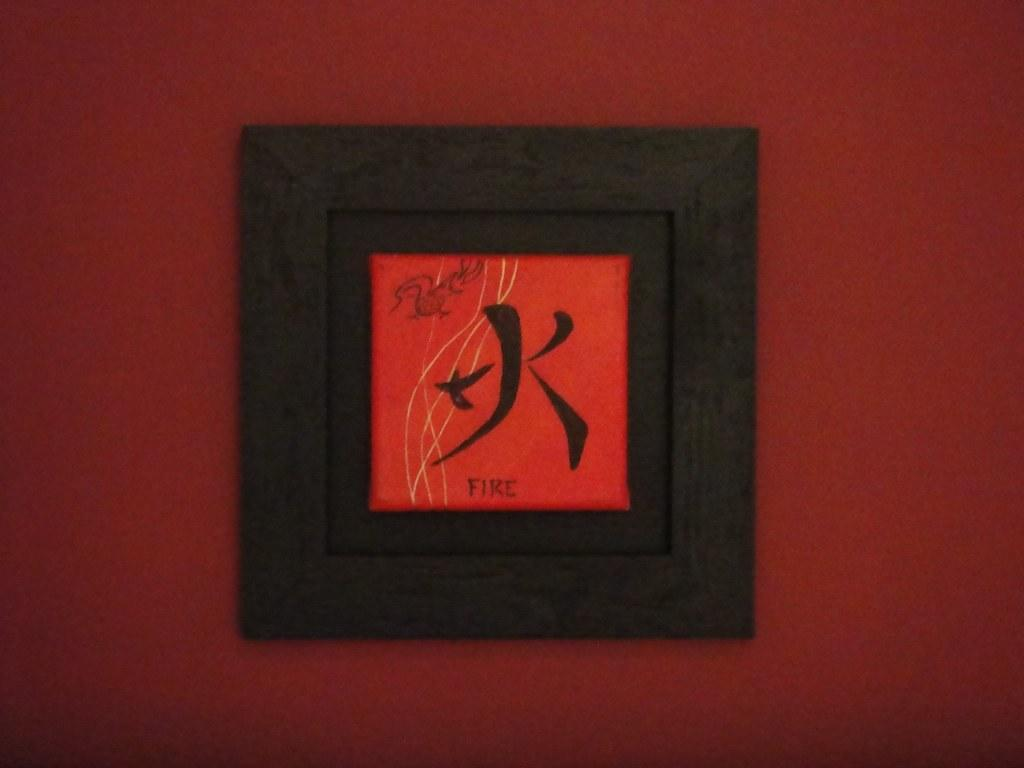<image>
Create a compact narrative representing the image presented. a frame with the word fire in Chinese charactor 